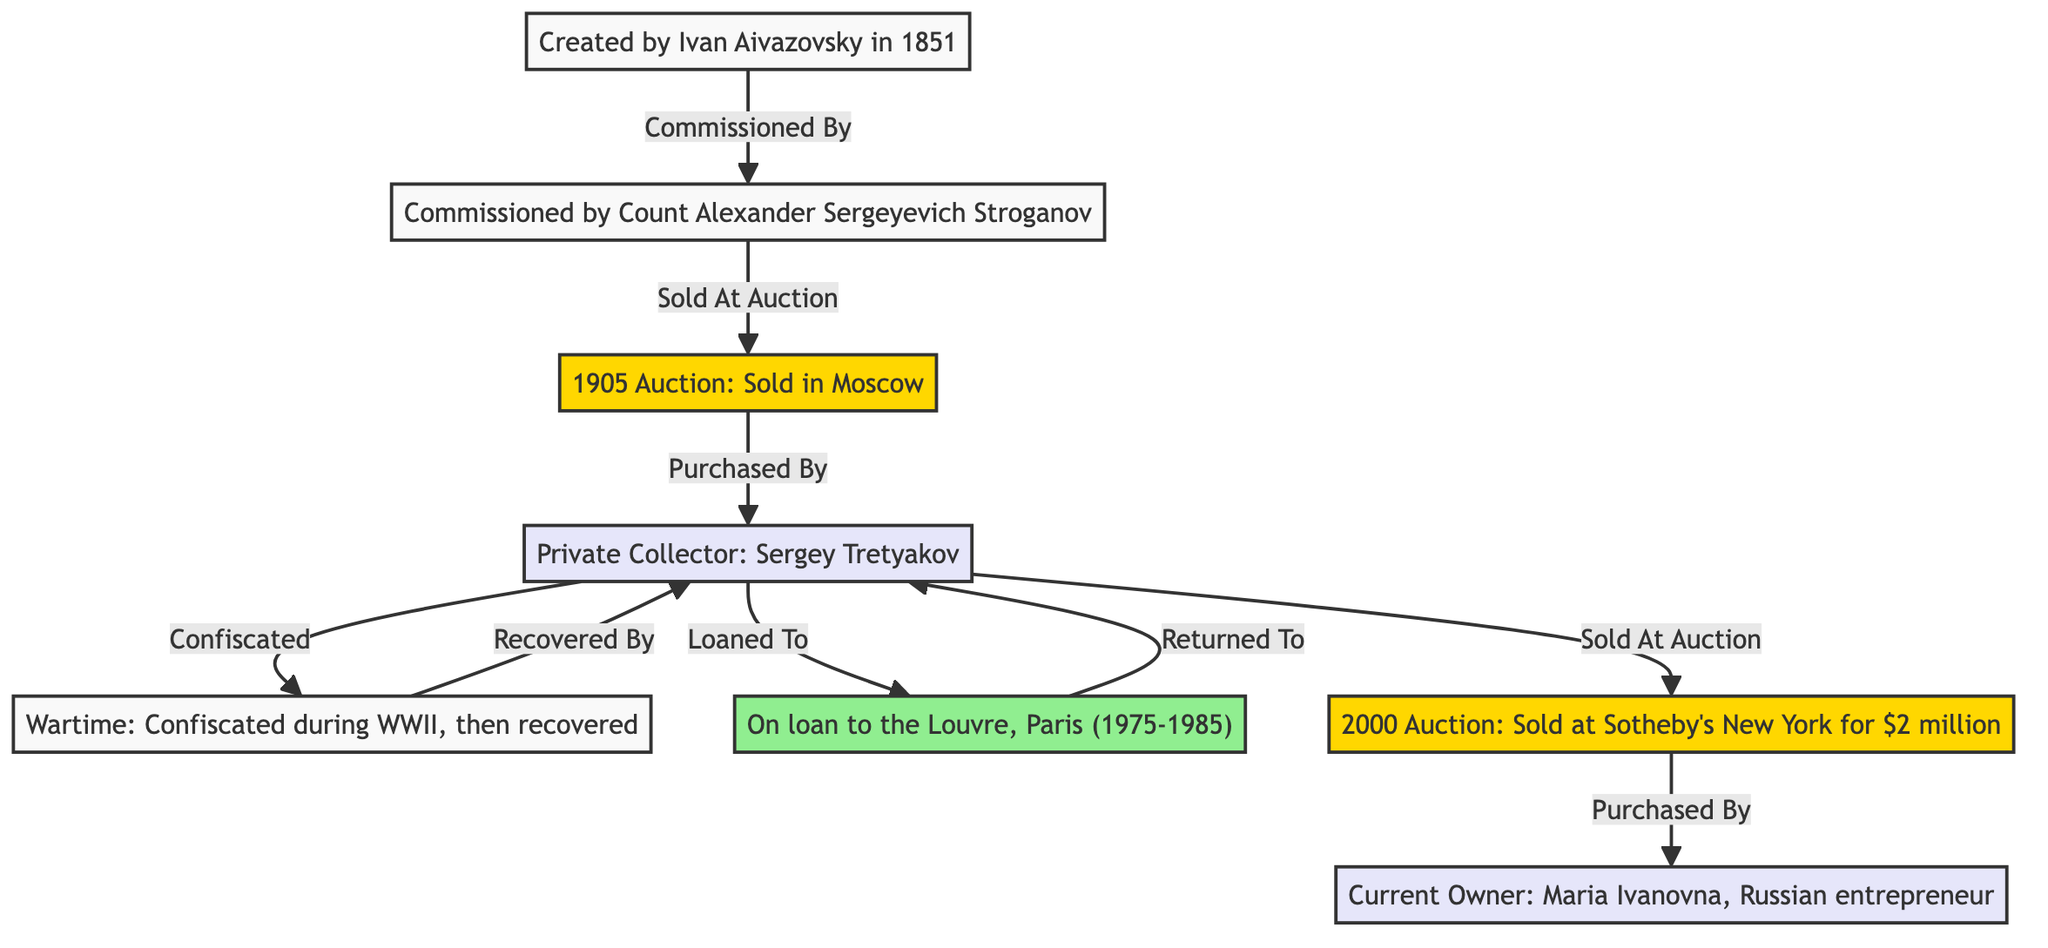What's the name of the artist who created the painting? The diagram shows that the painting was created by Ivan Aivazovsky. This information is found in the first node of the diagram.
Answer: Ivan Aivazovsky Who was the initial owner of the painting? According to the diagram, the painting was commissioned by Count Alexander Sergeyevich Stroganov, making him the initial owner. This is indicated in the second node.
Answer: Count Alexander Sergeyevich Stroganov How much was the painting sold for at the 2000 auction? The diagram specifies that the painting was sold at auction in 2000 for $2 million, which is stated clearly in the related auction node.
Answer: $2 million What event occurred during WWII regarding the painting? The flow in the diagram shows that during WWII, the painting was confiscated. This is clearly indicated in the wartime provenance section connecting to the owner from 1905 to 1950.
Answer: Confiscated How long was the painting on loan to the Louvre? The diagram indicates that the painting was on loan to the Louvre, Paris, from 1975 to 1985. This means it was loaned for a duration of 10 years.
Answer: 10 years Who is the current owner of the painting? The diagram indicates that the current owner of the painting is Maria Ivanovna, who is identified as a Russian entrepreneur. This is found in the last node of the diagram.
Answer: Maria Ivanovna What does the arrow from the auction in 1905 to the private collector indicate? The arrow represents the action of the painting being purchased by the private collector, Sergey Tretyakov, from the auction that took place in 1905. This is a direct relationship depicted in the flow of the diagram.
Answer: Purchased By What happened after the painting was recovered during wartime? The diagram shows that after the painting was confiscated during WWII, it was recovered by the same private collector, Sergey Tretyakov. This shows a return of ownership.
Answer: Recovered By 